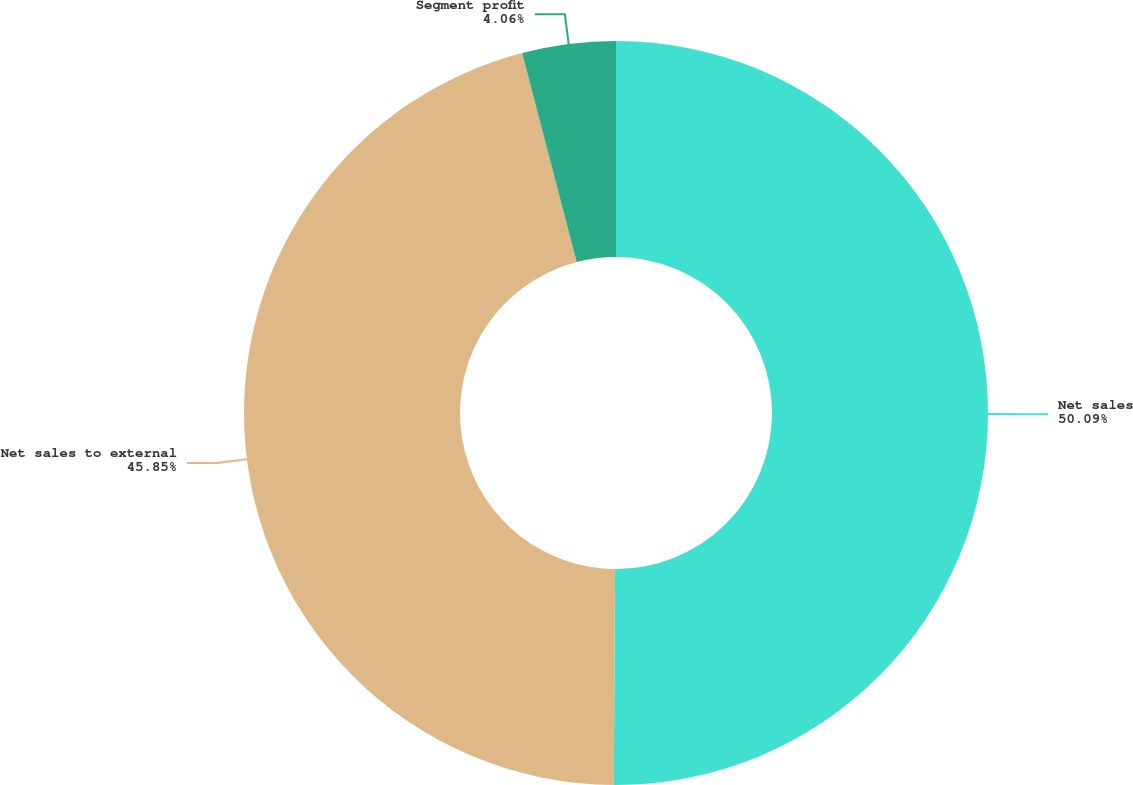Convert chart. <chart><loc_0><loc_0><loc_500><loc_500><pie_chart><fcel>Net sales<fcel>Net sales to external<fcel>Segment profit<nl><fcel>50.1%<fcel>45.85%<fcel>4.06%<nl></chart> 